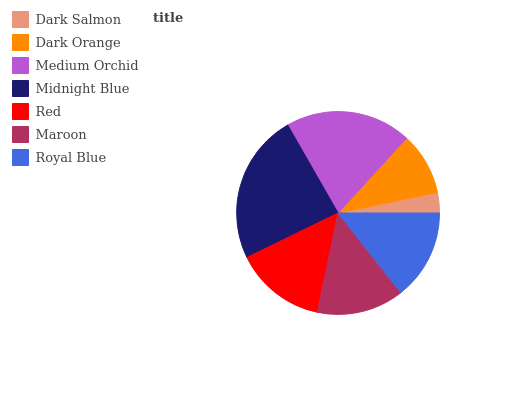Is Dark Salmon the minimum?
Answer yes or no. Yes. Is Midnight Blue the maximum?
Answer yes or no. Yes. Is Dark Orange the minimum?
Answer yes or no. No. Is Dark Orange the maximum?
Answer yes or no. No. Is Dark Orange greater than Dark Salmon?
Answer yes or no. Yes. Is Dark Salmon less than Dark Orange?
Answer yes or no. Yes. Is Dark Salmon greater than Dark Orange?
Answer yes or no. No. Is Dark Orange less than Dark Salmon?
Answer yes or no. No. Is Royal Blue the high median?
Answer yes or no. Yes. Is Royal Blue the low median?
Answer yes or no. Yes. Is Maroon the high median?
Answer yes or no. No. Is Midnight Blue the low median?
Answer yes or no. No. 